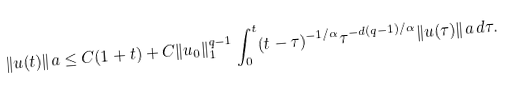<formula> <loc_0><loc_0><loc_500><loc_500>\| u ( t ) \| _ { \L } a \leq C ( 1 + t ) + C \| u _ { 0 } \| _ { 1 } ^ { q - 1 } \int _ { 0 } ^ { t } ( t - \tau ) ^ { - 1 / \alpha } \tau ^ { - d ( q - 1 ) / \alpha } \| u ( \tau ) \| _ { \L } a \, d \tau .</formula> 